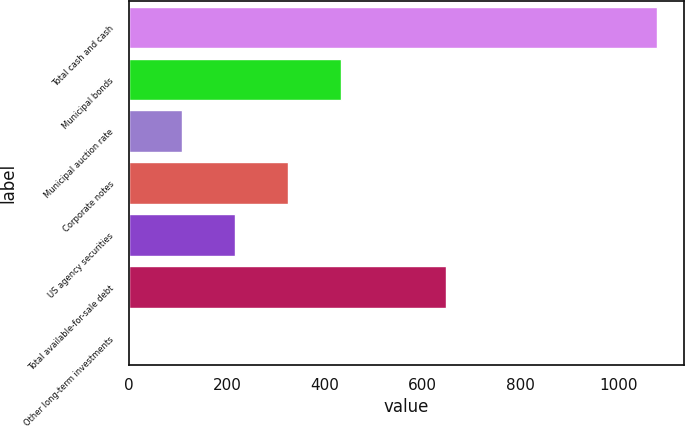<chart> <loc_0><loc_0><loc_500><loc_500><bar_chart><fcel>Total cash and cash<fcel>Municipal bonds<fcel>Municipal auction rate<fcel>Corporate notes<fcel>US agency securities<fcel>Total available-for-sale debt<fcel>Other long-term investments<nl><fcel>1079<fcel>432.2<fcel>108.8<fcel>324.4<fcel>216.6<fcel>647.8<fcel>1<nl></chart> 